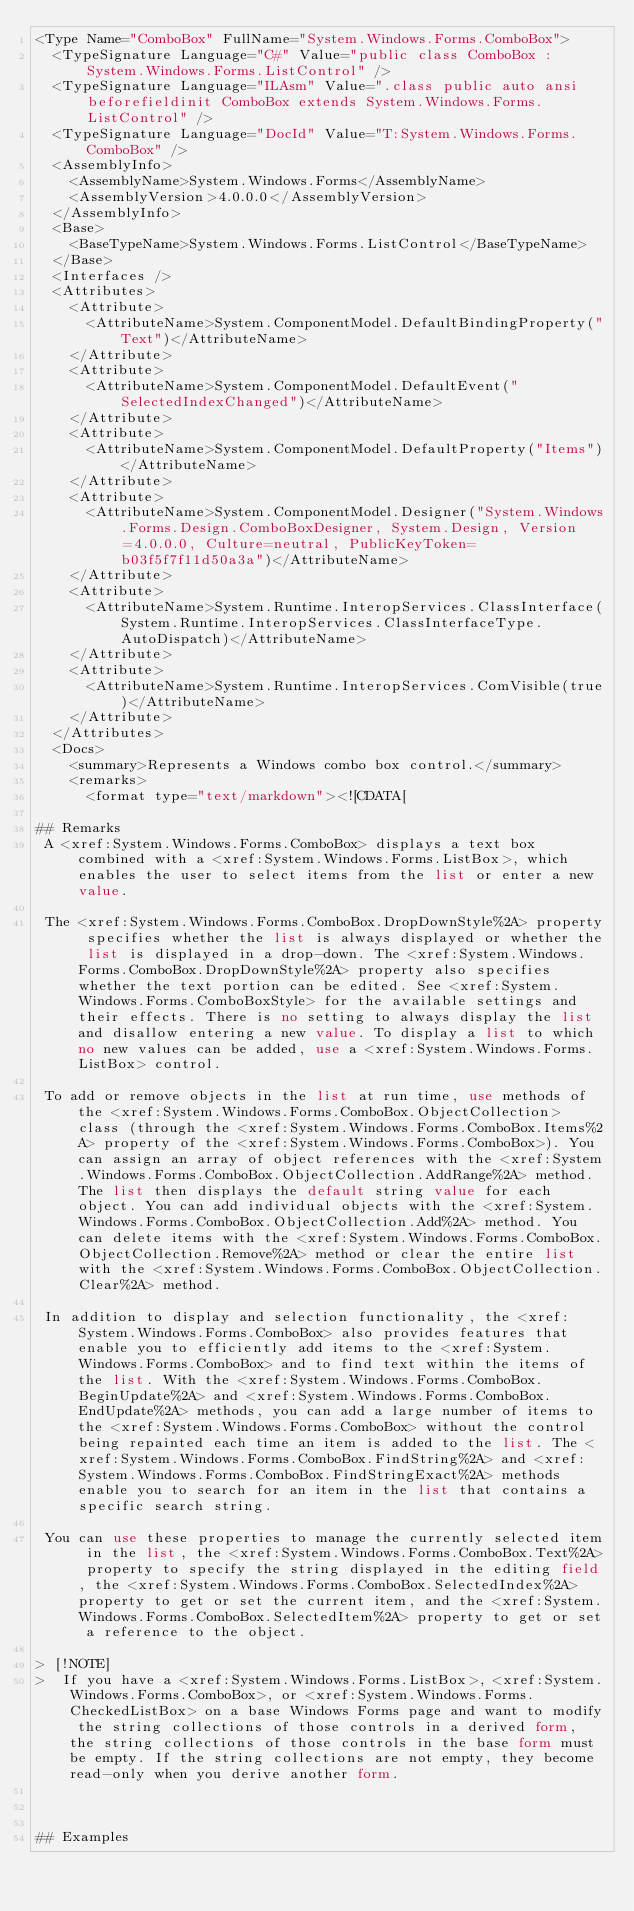<code> <loc_0><loc_0><loc_500><loc_500><_XML_><Type Name="ComboBox" FullName="System.Windows.Forms.ComboBox">
  <TypeSignature Language="C#" Value="public class ComboBox : System.Windows.Forms.ListControl" />
  <TypeSignature Language="ILAsm" Value=".class public auto ansi beforefieldinit ComboBox extends System.Windows.Forms.ListControl" />
  <TypeSignature Language="DocId" Value="T:System.Windows.Forms.ComboBox" />
  <AssemblyInfo>
    <AssemblyName>System.Windows.Forms</AssemblyName>
    <AssemblyVersion>4.0.0.0</AssemblyVersion>
  </AssemblyInfo>
  <Base>
    <BaseTypeName>System.Windows.Forms.ListControl</BaseTypeName>
  </Base>
  <Interfaces />
  <Attributes>
    <Attribute>
      <AttributeName>System.ComponentModel.DefaultBindingProperty("Text")</AttributeName>
    </Attribute>
    <Attribute>
      <AttributeName>System.ComponentModel.DefaultEvent("SelectedIndexChanged")</AttributeName>
    </Attribute>
    <Attribute>
      <AttributeName>System.ComponentModel.DefaultProperty("Items")</AttributeName>
    </Attribute>
    <Attribute>
      <AttributeName>System.ComponentModel.Designer("System.Windows.Forms.Design.ComboBoxDesigner, System.Design, Version=4.0.0.0, Culture=neutral, PublicKeyToken=b03f5f7f11d50a3a")</AttributeName>
    </Attribute>
    <Attribute>
      <AttributeName>System.Runtime.InteropServices.ClassInterface(System.Runtime.InteropServices.ClassInterfaceType.AutoDispatch)</AttributeName>
    </Attribute>
    <Attribute>
      <AttributeName>System.Runtime.InteropServices.ComVisible(true)</AttributeName>
    </Attribute>
  </Attributes>
  <Docs>
    <summary>Represents a Windows combo box control.</summary>
    <remarks>
      <format type="text/markdown"><![CDATA[  
  
## Remarks  
 A <xref:System.Windows.Forms.ComboBox> displays a text box combined with a <xref:System.Windows.Forms.ListBox>, which enables the user to select items from the list or enter a new value.  
  
 The <xref:System.Windows.Forms.ComboBox.DropDownStyle%2A> property specifies whether the list is always displayed or whether the list is displayed in a drop-down. The <xref:System.Windows.Forms.ComboBox.DropDownStyle%2A> property also specifies whether the text portion can be edited. See <xref:System.Windows.Forms.ComboBoxStyle> for the available settings and their effects. There is no setting to always display the list and disallow entering a new value. To display a list to which no new values can be added, use a <xref:System.Windows.Forms.ListBox> control.  
  
 To add or remove objects in the list at run time, use methods of the <xref:System.Windows.Forms.ComboBox.ObjectCollection> class (through the <xref:System.Windows.Forms.ComboBox.Items%2A> property of the <xref:System.Windows.Forms.ComboBox>). You can assign an array of object references with the <xref:System.Windows.Forms.ComboBox.ObjectCollection.AddRange%2A> method. The list then displays the default string value for each object. You can add individual objects with the <xref:System.Windows.Forms.ComboBox.ObjectCollection.Add%2A> method. You can delete items with the <xref:System.Windows.Forms.ComboBox.ObjectCollection.Remove%2A> method or clear the entire list with the <xref:System.Windows.Forms.ComboBox.ObjectCollection.Clear%2A> method.  
  
 In addition to display and selection functionality, the <xref:System.Windows.Forms.ComboBox> also provides features that enable you to efficiently add items to the <xref:System.Windows.Forms.ComboBox> and to find text within the items of the list. With the <xref:System.Windows.Forms.ComboBox.BeginUpdate%2A> and <xref:System.Windows.Forms.ComboBox.EndUpdate%2A> methods, you can add a large number of items to the <xref:System.Windows.Forms.ComboBox> without the control being repainted each time an item is added to the list. The <xref:System.Windows.Forms.ComboBox.FindString%2A> and <xref:System.Windows.Forms.ComboBox.FindStringExact%2A> methods enable you to search for an item in the list that contains a specific search string.  
  
 You can use these properties to manage the currently selected item in the list, the <xref:System.Windows.Forms.ComboBox.Text%2A> property to specify the string displayed in the editing field, the <xref:System.Windows.Forms.ComboBox.SelectedIndex%2A> property to get or set the current item, and the <xref:System.Windows.Forms.ComboBox.SelectedItem%2A> property to get or set a reference to the object.  
  
> [!NOTE]
>  If you have a <xref:System.Windows.Forms.ListBox>, <xref:System.Windows.Forms.ComboBox>, or <xref:System.Windows.Forms.CheckedListBox> on a base Windows Forms page and want to modify the string collections of those controls in a derived form, the string collections of those controls in the base form must be empty. If the string collections are not empty, they become read-only when you derive another form.  
  
   
  
## Examples  </code> 